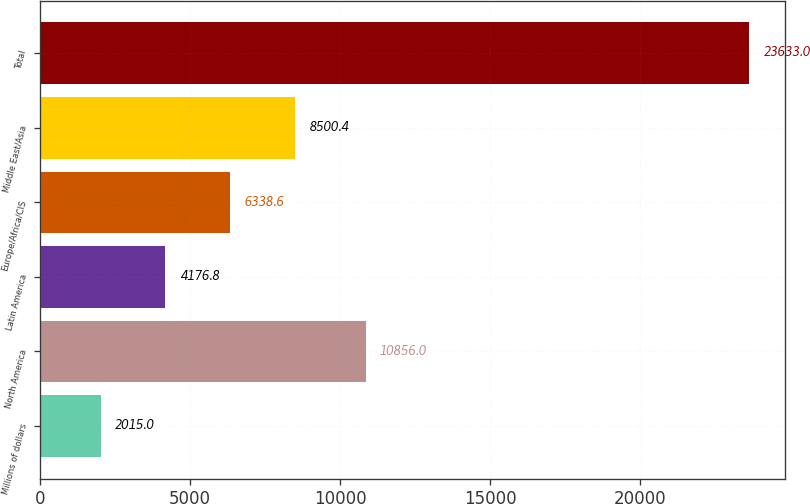Convert chart. <chart><loc_0><loc_0><loc_500><loc_500><bar_chart><fcel>Millions of dollars<fcel>North America<fcel>Latin America<fcel>Europe/Africa/CIS<fcel>Middle East/Asia<fcel>Total<nl><fcel>2015<fcel>10856<fcel>4176.8<fcel>6338.6<fcel>8500.4<fcel>23633<nl></chart> 